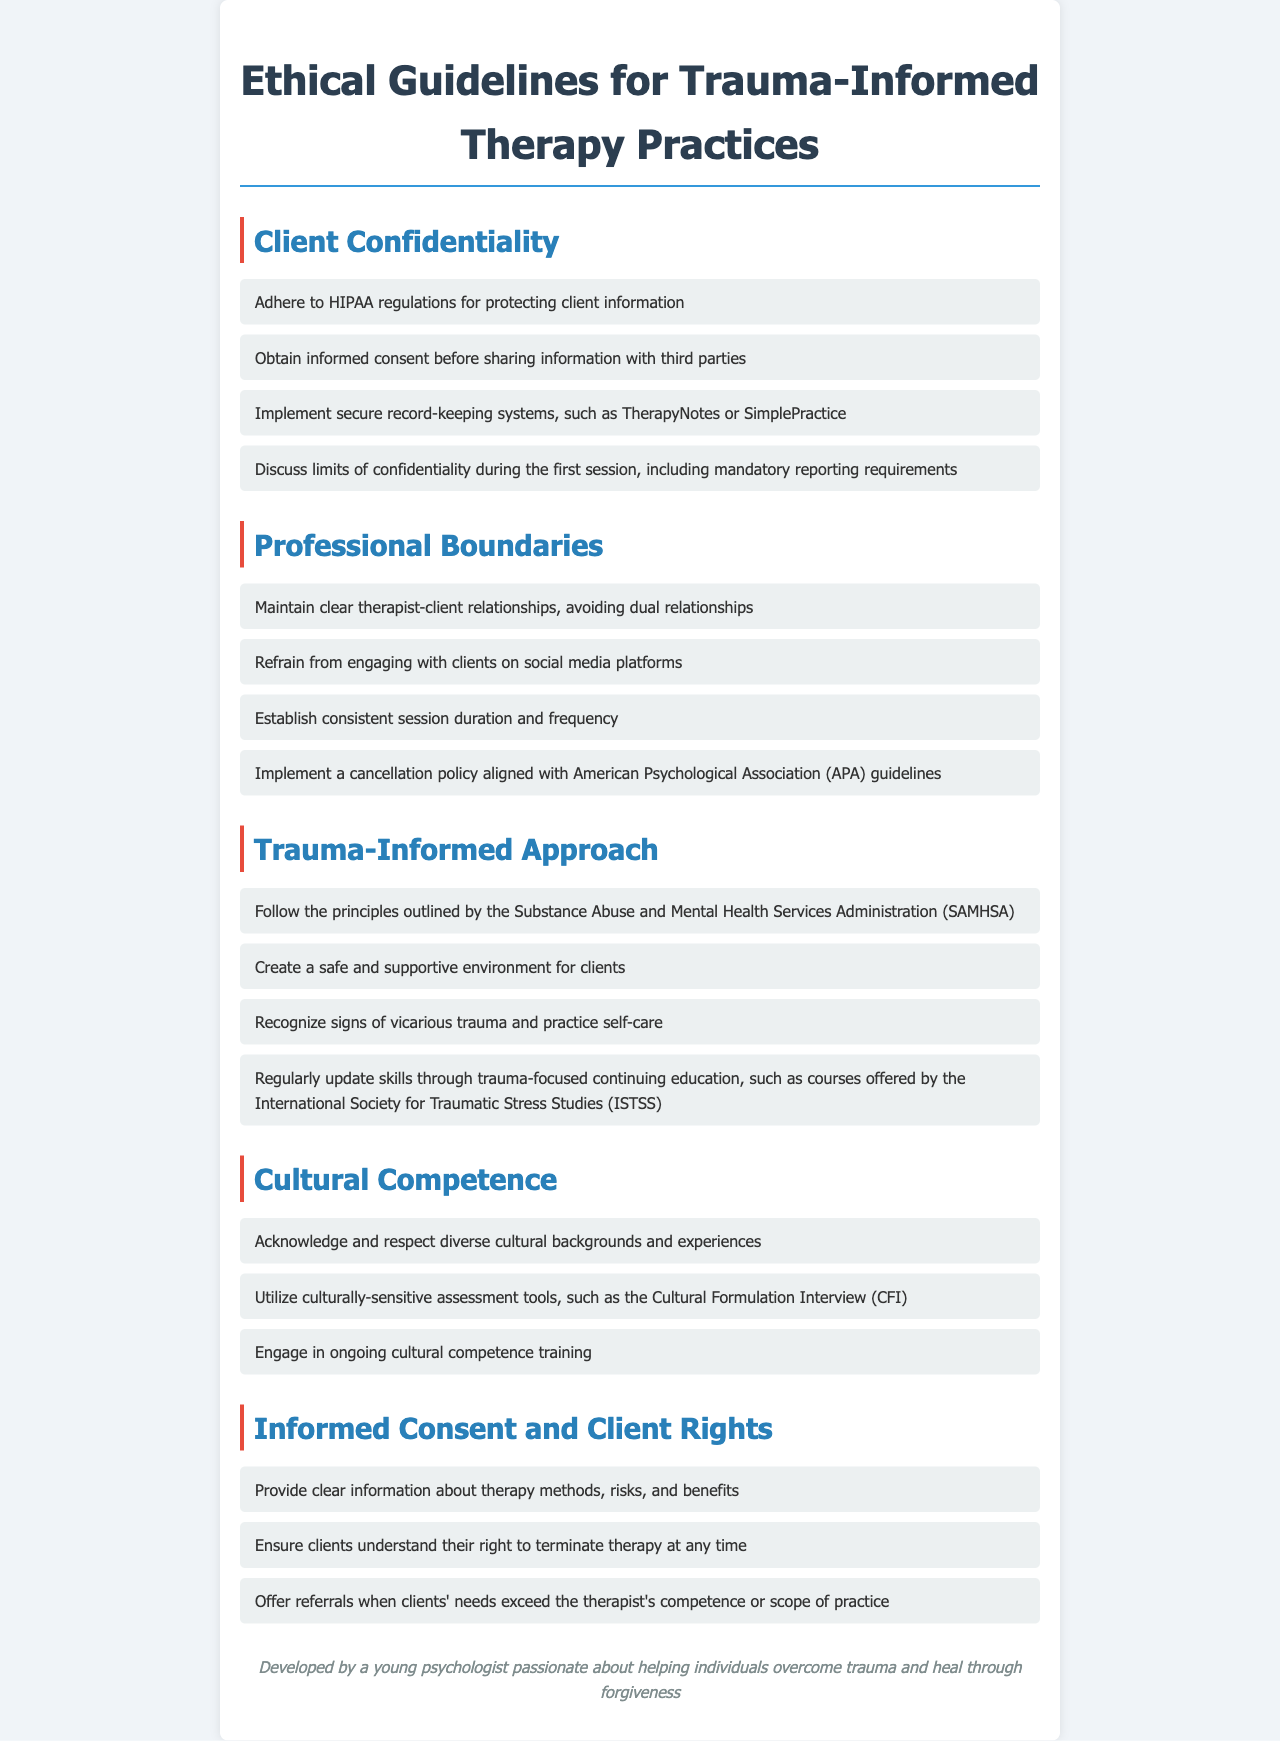What regulations must be adhered to for protecting client information? HIPAA is referenced as the standard for protecting client information in the confidentiality section.
Answer: HIPAA What should be discussed regarding confidentiality during the first session? The document specifies that limits of confidentiality and mandatory reporting requirements should be discussed.
Answer: Limits of confidentiality What should be avoided to maintain professional boundaries? The document advises against engaging with clients on social media platforms.
Answer: Social media platforms Which organization’s guidelines should be followed for a cancellation policy? The American Psychological Association (APA) is mentioned as the source for guidance on cancellation policies.
Answer: American Psychological Association (APA) What approach should be followed according to SAMHSA? The principles outlined by the Substance Abuse and Mental Health Services Administration (SAMHSA) should be followed for a trauma-informed approach.
Answer: SAMHSA What type of training should be engaged in for cultural competence? Continuing education that focuses on cultural competence is recommended in the document.
Answer: Ongoing cultural competence training What rights do clients have regarding therapy termination? Clients have the right to terminate therapy at any time according to the informed consent section.
Answer: Terminate therapy at any time What is a recommended assessment tool for cultural backgrounds? The Cultural Formulation Interview (CFI) is recommended as a culturally-sensitive assessment tool.
Answer: Cultural Formulation Interview (CFI) 